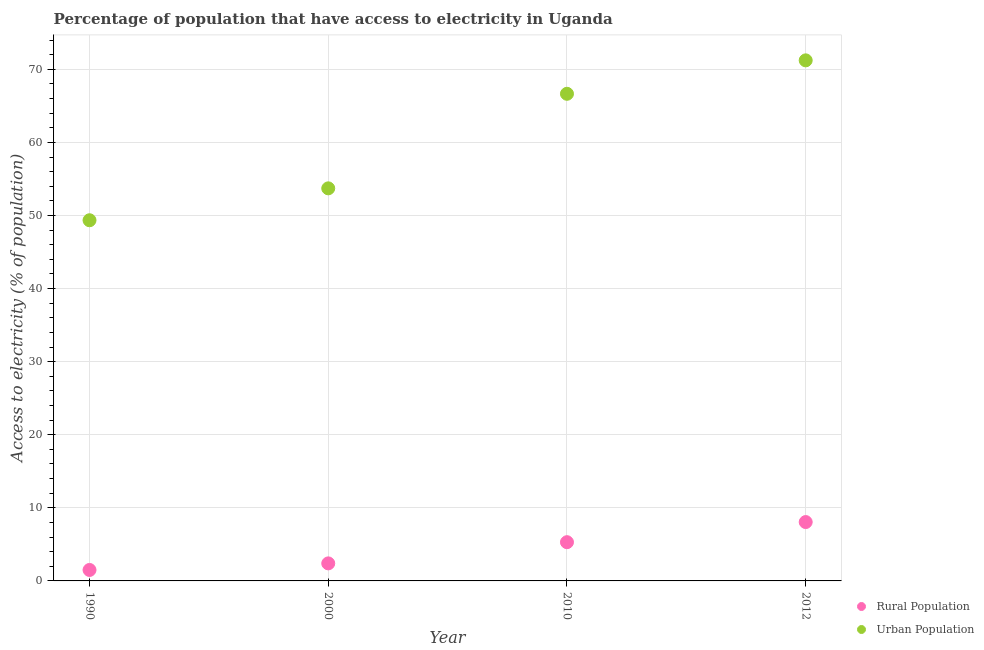How many different coloured dotlines are there?
Your answer should be very brief. 2. Across all years, what is the maximum percentage of rural population having access to electricity?
Provide a succinct answer. 8.05. Across all years, what is the minimum percentage of urban population having access to electricity?
Give a very brief answer. 49.35. In which year was the percentage of urban population having access to electricity minimum?
Provide a short and direct response. 1990. What is the total percentage of rural population having access to electricity in the graph?
Your response must be concise. 17.25. What is the difference between the percentage of rural population having access to electricity in 1990 and that in 2000?
Ensure brevity in your answer.  -0.9. What is the difference between the percentage of rural population having access to electricity in 2010 and the percentage of urban population having access to electricity in 2000?
Your answer should be very brief. -48.42. What is the average percentage of rural population having access to electricity per year?
Give a very brief answer. 4.31. In the year 2012, what is the difference between the percentage of urban population having access to electricity and percentage of rural population having access to electricity?
Your answer should be compact. 63.17. What is the ratio of the percentage of rural population having access to electricity in 1990 to that in 2012?
Offer a very short reply. 0.19. What is the difference between the highest and the second highest percentage of rural population having access to electricity?
Keep it short and to the point. 2.75. What is the difference between the highest and the lowest percentage of urban population having access to electricity?
Your answer should be compact. 21.88. Is the sum of the percentage of urban population having access to electricity in 2010 and 2012 greater than the maximum percentage of rural population having access to electricity across all years?
Offer a very short reply. Yes. Does the percentage of urban population having access to electricity monotonically increase over the years?
Provide a succinct answer. Yes. Is the percentage of rural population having access to electricity strictly greater than the percentage of urban population having access to electricity over the years?
Give a very brief answer. No. How many years are there in the graph?
Offer a very short reply. 4. How are the legend labels stacked?
Keep it short and to the point. Vertical. What is the title of the graph?
Your answer should be very brief. Percentage of population that have access to electricity in Uganda. What is the label or title of the Y-axis?
Ensure brevity in your answer.  Access to electricity (% of population). What is the Access to electricity (% of population) of Urban Population in 1990?
Give a very brief answer. 49.35. What is the Access to electricity (% of population) in Rural Population in 2000?
Ensure brevity in your answer.  2.4. What is the Access to electricity (% of population) in Urban Population in 2000?
Make the answer very short. 53.72. What is the Access to electricity (% of population) in Urban Population in 2010?
Provide a short and direct response. 66.65. What is the Access to electricity (% of population) of Rural Population in 2012?
Offer a terse response. 8.05. What is the Access to electricity (% of population) of Urban Population in 2012?
Provide a short and direct response. 71.23. Across all years, what is the maximum Access to electricity (% of population) of Rural Population?
Keep it short and to the point. 8.05. Across all years, what is the maximum Access to electricity (% of population) in Urban Population?
Make the answer very short. 71.23. Across all years, what is the minimum Access to electricity (% of population) of Rural Population?
Your response must be concise. 1.5. Across all years, what is the minimum Access to electricity (% of population) of Urban Population?
Give a very brief answer. 49.35. What is the total Access to electricity (% of population) of Rural Population in the graph?
Ensure brevity in your answer.  17.25. What is the total Access to electricity (% of population) of Urban Population in the graph?
Your answer should be compact. 240.95. What is the difference between the Access to electricity (% of population) of Rural Population in 1990 and that in 2000?
Your answer should be very brief. -0.9. What is the difference between the Access to electricity (% of population) in Urban Population in 1990 and that in 2000?
Your answer should be very brief. -4.36. What is the difference between the Access to electricity (% of population) of Rural Population in 1990 and that in 2010?
Offer a terse response. -3.8. What is the difference between the Access to electricity (% of population) in Urban Population in 1990 and that in 2010?
Provide a succinct answer. -17.3. What is the difference between the Access to electricity (% of population) in Rural Population in 1990 and that in 2012?
Provide a short and direct response. -6.55. What is the difference between the Access to electricity (% of population) of Urban Population in 1990 and that in 2012?
Give a very brief answer. -21.88. What is the difference between the Access to electricity (% of population) of Urban Population in 2000 and that in 2010?
Give a very brief answer. -12.94. What is the difference between the Access to electricity (% of population) of Rural Population in 2000 and that in 2012?
Your response must be concise. -5.65. What is the difference between the Access to electricity (% of population) in Urban Population in 2000 and that in 2012?
Your response must be concise. -17.51. What is the difference between the Access to electricity (% of population) in Rural Population in 2010 and that in 2012?
Offer a very short reply. -2.75. What is the difference between the Access to electricity (% of population) in Urban Population in 2010 and that in 2012?
Your answer should be very brief. -4.58. What is the difference between the Access to electricity (% of population) of Rural Population in 1990 and the Access to electricity (% of population) of Urban Population in 2000?
Provide a succinct answer. -52.22. What is the difference between the Access to electricity (% of population) of Rural Population in 1990 and the Access to electricity (% of population) of Urban Population in 2010?
Give a very brief answer. -65.15. What is the difference between the Access to electricity (% of population) of Rural Population in 1990 and the Access to electricity (% of population) of Urban Population in 2012?
Make the answer very short. -69.73. What is the difference between the Access to electricity (% of population) of Rural Population in 2000 and the Access to electricity (% of population) of Urban Population in 2010?
Provide a short and direct response. -64.25. What is the difference between the Access to electricity (% of population) of Rural Population in 2000 and the Access to electricity (% of population) of Urban Population in 2012?
Your answer should be compact. -68.83. What is the difference between the Access to electricity (% of population) in Rural Population in 2010 and the Access to electricity (% of population) in Urban Population in 2012?
Ensure brevity in your answer.  -65.93. What is the average Access to electricity (% of population) in Rural Population per year?
Offer a very short reply. 4.31. What is the average Access to electricity (% of population) in Urban Population per year?
Your answer should be very brief. 60.24. In the year 1990, what is the difference between the Access to electricity (% of population) in Rural Population and Access to electricity (% of population) in Urban Population?
Keep it short and to the point. -47.85. In the year 2000, what is the difference between the Access to electricity (% of population) in Rural Population and Access to electricity (% of population) in Urban Population?
Your response must be concise. -51.32. In the year 2010, what is the difference between the Access to electricity (% of population) in Rural Population and Access to electricity (% of population) in Urban Population?
Offer a terse response. -61.35. In the year 2012, what is the difference between the Access to electricity (% of population) in Rural Population and Access to electricity (% of population) in Urban Population?
Ensure brevity in your answer.  -63.17. What is the ratio of the Access to electricity (% of population) in Urban Population in 1990 to that in 2000?
Keep it short and to the point. 0.92. What is the ratio of the Access to electricity (% of population) of Rural Population in 1990 to that in 2010?
Ensure brevity in your answer.  0.28. What is the ratio of the Access to electricity (% of population) of Urban Population in 1990 to that in 2010?
Make the answer very short. 0.74. What is the ratio of the Access to electricity (% of population) of Rural Population in 1990 to that in 2012?
Keep it short and to the point. 0.19. What is the ratio of the Access to electricity (% of population) of Urban Population in 1990 to that in 2012?
Keep it short and to the point. 0.69. What is the ratio of the Access to electricity (% of population) of Rural Population in 2000 to that in 2010?
Your answer should be very brief. 0.45. What is the ratio of the Access to electricity (% of population) in Urban Population in 2000 to that in 2010?
Ensure brevity in your answer.  0.81. What is the ratio of the Access to electricity (% of population) in Rural Population in 2000 to that in 2012?
Your answer should be compact. 0.3. What is the ratio of the Access to electricity (% of population) in Urban Population in 2000 to that in 2012?
Ensure brevity in your answer.  0.75. What is the ratio of the Access to electricity (% of population) of Rural Population in 2010 to that in 2012?
Keep it short and to the point. 0.66. What is the ratio of the Access to electricity (% of population) of Urban Population in 2010 to that in 2012?
Offer a terse response. 0.94. What is the difference between the highest and the second highest Access to electricity (% of population) of Rural Population?
Make the answer very short. 2.75. What is the difference between the highest and the second highest Access to electricity (% of population) in Urban Population?
Keep it short and to the point. 4.58. What is the difference between the highest and the lowest Access to electricity (% of population) in Rural Population?
Your response must be concise. 6.55. What is the difference between the highest and the lowest Access to electricity (% of population) of Urban Population?
Your answer should be compact. 21.88. 